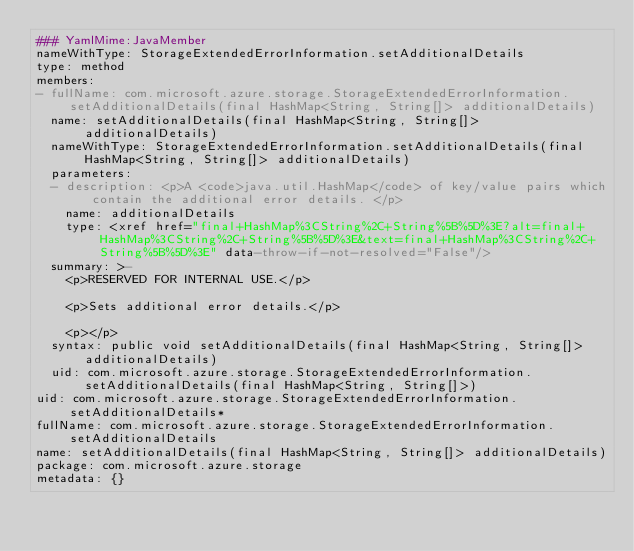Convert code to text. <code><loc_0><loc_0><loc_500><loc_500><_YAML_>### YamlMime:JavaMember
nameWithType: StorageExtendedErrorInformation.setAdditionalDetails
type: method
members:
- fullName: com.microsoft.azure.storage.StorageExtendedErrorInformation.setAdditionalDetails(final HashMap<String, String[]> additionalDetails)
  name: setAdditionalDetails(final HashMap<String, String[]> additionalDetails)
  nameWithType: StorageExtendedErrorInformation.setAdditionalDetails(final HashMap<String, String[]> additionalDetails)
  parameters:
  - description: <p>A <code>java.util.HashMap</code> of key/value pairs which contain the additional error details. </p>
    name: additionalDetails
    type: <xref href="final+HashMap%3CString%2C+String%5B%5D%3E?alt=final+HashMap%3CString%2C+String%5B%5D%3E&text=final+HashMap%3CString%2C+String%5B%5D%3E" data-throw-if-not-resolved="False"/>
  summary: >-
    <p>RESERVED FOR INTERNAL USE.</p>

    <p>Sets additional error details.</p>

    <p></p>
  syntax: public void setAdditionalDetails(final HashMap<String, String[]> additionalDetails)
  uid: com.microsoft.azure.storage.StorageExtendedErrorInformation.setAdditionalDetails(final HashMap<String, String[]>)
uid: com.microsoft.azure.storage.StorageExtendedErrorInformation.setAdditionalDetails*
fullName: com.microsoft.azure.storage.StorageExtendedErrorInformation.setAdditionalDetails
name: setAdditionalDetails(final HashMap<String, String[]> additionalDetails)
package: com.microsoft.azure.storage
metadata: {}
</code> 